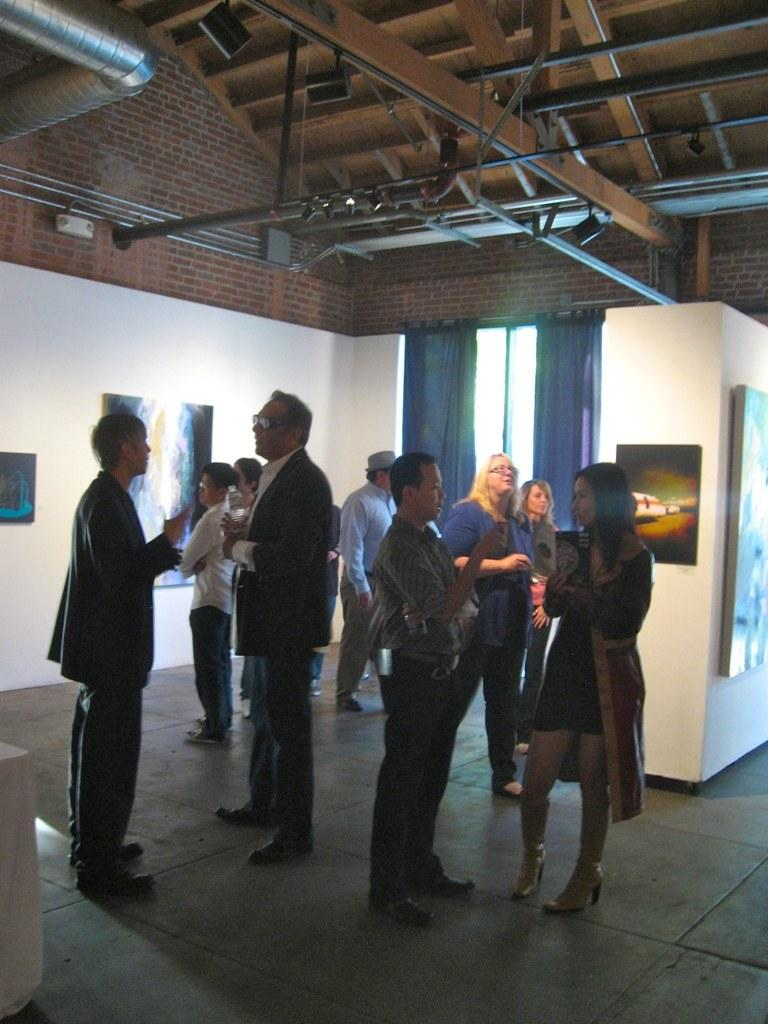What can be seen in the image? There are people standing in the image. Where are the people standing? The people are standing on the floor. What can be seen on the wall in the background? There are photo frames on the wall in the background. What is visible above the people in the image? There is a roof visible in the image. How many bikes are being ridden by the people in the image? There are no bikes present in the image; the people are standing on the floor. What impulse might have caused the people to gather in the image? The image does not provide any information about the reason for the people gathering, so we cannot determine the impulse that brought them together. 